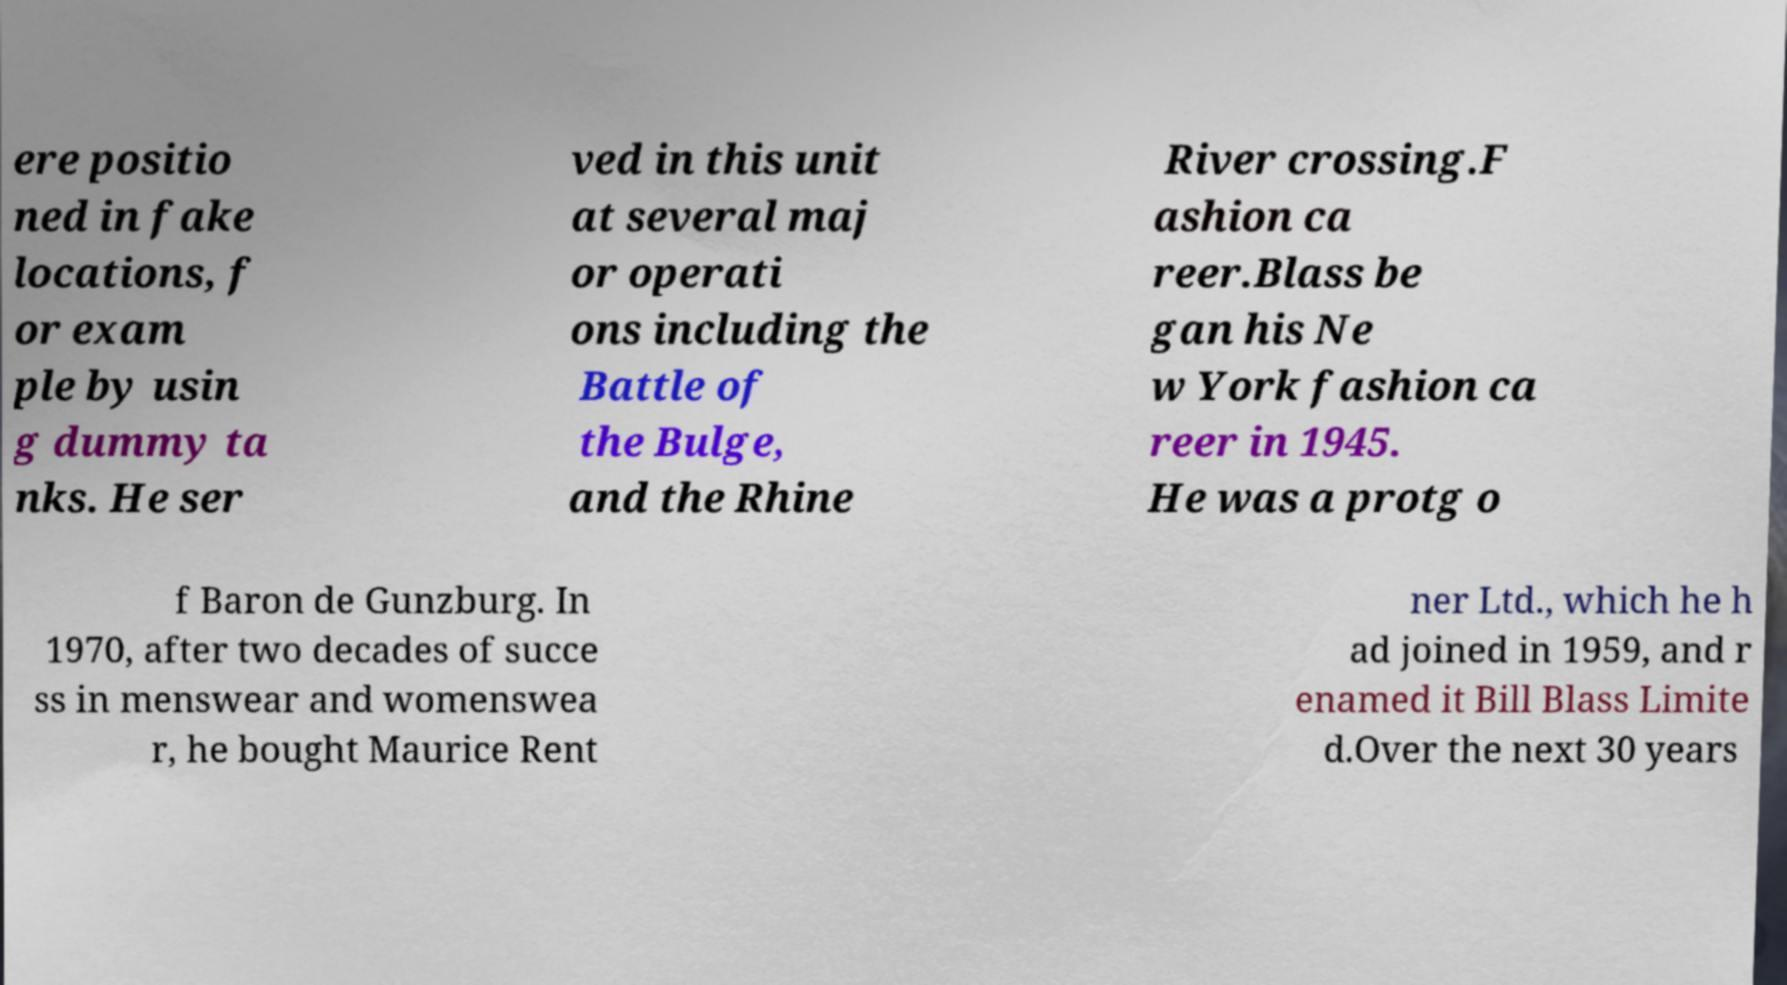Please identify and transcribe the text found in this image. ere positio ned in fake locations, f or exam ple by usin g dummy ta nks. He ser ved in this unit at several maj or operati ons including the Battle of the Bulge, and the Rhine River crossing.F ashion ca reer.Blass be gan his Ne w York fashion ca reer in 1945. He was a protg o f Baron de Gunzburg. In 1970, after two decades of succe ss in menswear and womenswea r, he bought Maurice Rent ner Ltd., which he h ad joined in 1959, and r enamed it Bill Blass Limite d.Over the next 30 years 